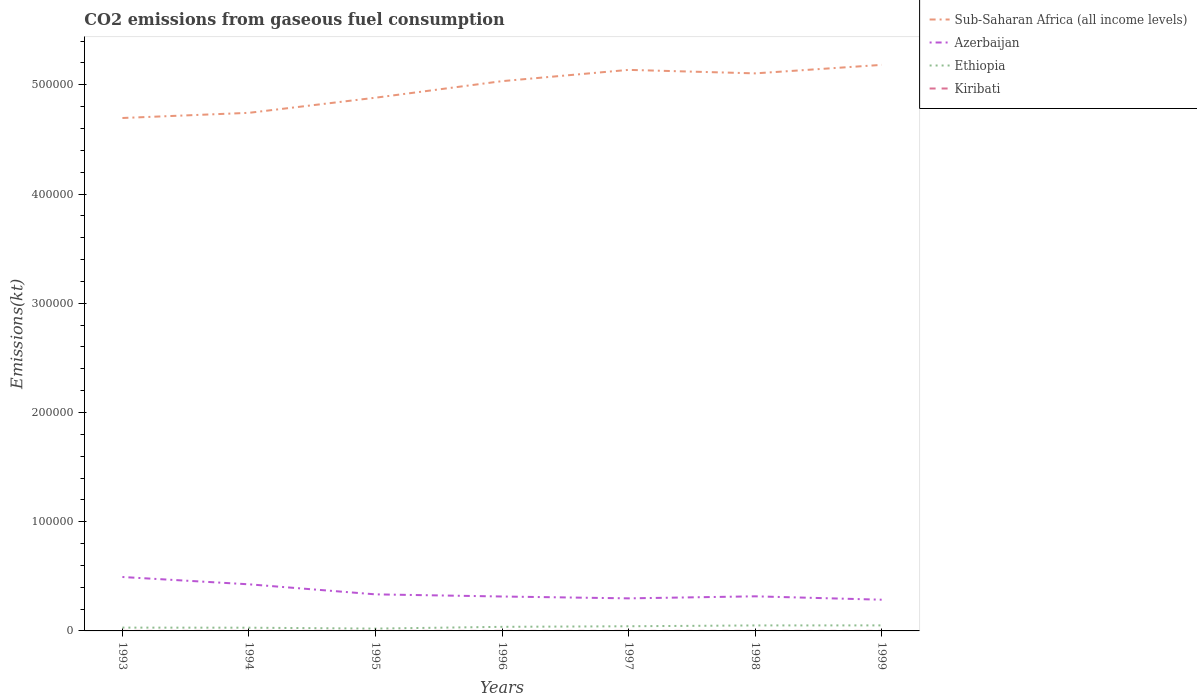How many different coloured lines are there?
Offer a very short reply. 4. Does the line corresponding to Ethiopia intersect with the line corresponding to Azerbaijan?
Provide a short and direct response. No. Across all years, what is the maximum amount of CO2 emitted in Azerbaijan?
Your response must be concise. 2.86e+04. What is the total amount of CO2 emitted in Sub-Saharan Africa (all income levels) in the graph?
Your answer should be very brief. 3200.52. What is the difference between the highest and the second highest amount of CO2 emitted in Azerbaijan?
Your answer should be very brief. 2.08e+04. What is the difference between the highest and the lowest amount of CO2 emitted in Ethiopia?
Ensure brevity in your answer.  3. How many lines are there?
Offer a terse response. 4. Are the values on the major ticks of Y-axis written in scientific E-notation?
Your response must be concise. No. Where does the legend appear in the graph?
Your answer should be very brief. Top right. What is the title of the graph?
Your response must be concise. CO2 emissions from gaseous fuel consumption. What is the label or title of the X-axis?
Provide a short and direct response. Years. What is the label or title of the Y-axis?
Offer a very short reply. Emissions(kt). What is the Emissions(kt) of Sub-Saharan Africa (all income levels) in 1993?
Provide a succinct answer. 4.70e+05. What is the Emissions(kt) in Azerbaijan in 1993?
Your answer should be compact. 4.94e+04. What is the Emissions(kt) in Ethiopia in 1993?
Offer a very short reply. 3028.94. What is the Emissions(kt) of Kiribati in 1993?
Make the answer very short. 22. What is the Emissions(kt) in Sub-Saharan Africa (all income levels) in 1994?
Ensure brevity in your answer.  4.74e+05. What is the Emissions(kt) in Azerbaijan in 1994?
Ensure brevity in your answer.  4.27e+04. What is the Emissions(kt) of Ethiopia in 1994?
Your answer should be very brief. 2948.27. What is the Emissions(kt) in Kiribati in 1994?
Provide a short and direct response. 22. What is the Emissions(kt) in Sub-Saharan Africa (all income levels) in 1995?
Make the answer very short. 4.88e+05. What is the Emissions(kt) in Azerbaijan in 1995?
Your answer should be compact. 3.35e+04. What is the Emissions(kt) in Ethiopia in 1995?
Your answer should be very brief. 2145.2. What is the Emissions(kt) of Kiribati in 1995?
Give a very brief answer. 22. What is the Emissions(kt) in Sub-Saharan Africa (all income levels) in 1996?
Provide a succinct answer. 5.03e+05. What is the Emissions(kt) in Azerbaijan in 1996?
Ensure brevity in your answer.  3.15e+04. What is the Emissions(kt) in Ethiopia in 1996?
Keep it short and to the point. 3744.01. What is the Emissions(kt) in Kiribati in 1996?
Provide a short and direct response. 36.67. What is the Emissions(kt) of Sub-Saharan Africa (all income levels) in 1997?
Ensure brevity in your answer.  5.14e+05. What is the Emissions(kt) in Azerbaijan in 1997?
Your response must be concise. 2.98e+04. What is the Emissions(kt) in Ethiopia in 1997?
Ensure brevity in your answer.  4272.06. What is the Emissions(kt) of Kiribati in 1997?
Your response must be concise. 29.34. What is the Emissions(kt) in Sub-Saharan Africa (all income levels) in 1998?
Your answer should be very brief. 5.10e+05. What is the Emissions(kt) of Azerbaijan in 1998?
Your answer should be very brief. 3.17e+04. What is the Emissions(kt) in Ethiopia in 1998?
Make the answer very short. 5023.79. What is the Emissions(kt) of Kiribati in 1998?
Your answer should be compact. 33. What is the Emissions(kt) of Sub-Saharan Africa (all income levels) in 1999?
Your response must be concise. 5.18e+05. What is the Emissions(kt) in Azerbaijan in 1999?
Keep it short and to the point. 2.86e+04. What is the Emissions(kt) of Ethiopia in 1999?
Provide a short and direct response. 5064.13. What is the Emissions(kt) of Kiribati in 1999?
Your answer should be compact. 29.34. Across all years, what is the maximum Emissions(kt) in Sub-Saharan Africa (all income levels)?
Offer a terse response. 5.18e+05. Across all years, what is the maximum Emissions(kt) in Azerbaijan?
Ensure brevity in your answer.  4.94e+04. Across all years, what is the maximum Emissions(kt) in Ethiopia?
Offer a very short reply. 5064.13. Across all years, what is the maximum Emissions(kt) in Kiribati?
Make the answer very short. 36.67. Across all years, what is the minimum Emissions(kt) in Sub-Saharan Africa (all income levels)?
Your answer should be compact. 4.70e+05. Across all years, what is the minimum Emissions(kt) of Azerbaijan?
Provide a short and direct response. 2.86e+04. Across all years, what is the minimum Emissions(kt) of Ethiopia?
Your answer should be very brief. 2145.2. Across all years, what is the minimum Emissions(kt) of Kiribati?
Offer a terse response. 22. What is the total Emissions(kt) in Sub-Saharan Africa (all income levels) in the graph?
Give a very brief answer. 3.48e+06. What is the total Emissions(kt) in Azerbaijan in the graph?
Give a very brief answer. 2.47e+05. What is the total Emissions(kt) in Ethiopia in the graph?
Make the answer very short. 2.62e+04. What is the total Emissions(kt) of Kiribati in the graph?
Provide a succinct answer. 194.35. What is the difference between the Emissions(kt) in Sub-Saharan Africa (all income levels) in 1993 and that in 1994?
Offer a terse response. -4729.34. What is the difference between the Emissions(kt) in Azerbaijan in 1993 and that in 1994?
Your response must be concise. 6692.27. What is the difference between the Emissions(kt) of Ethiopia in 1993 and that in 1994?
Your response must be concise. 80.67. What is the difference between the Emissions(kt) in Kiribati in 1993 and that in 1994?
Your answer should be compact. 0. What is the difference between the Emissions(kt) in Sub-Saharan Africa (all income levels) in 1993 and that in 1995?
Your response must be concise. -1.86e+04. What is the difference between the Emissions(kt) of Azerbaijan in 1993 and that in 1995?
Offer a terse response. 1.59e+04. What is the difference between the Emissions(kt) in Ethiopia in 1993 and that in 1995?
Provide a short and direct response. 883.75. What is the difference between the Emissions(kt) in Kiribati in 1993 and that in 1995?
Keep it short and to the point. 0. What is the difference between the Emissions(kt) in Sub-Saharan Africa (all income levels) in 1993 and that in 1996?
Offer a very short reply. -3.37e+04. What is the difference between the Emissions(kt) of Azerbaijan in 1993 and that in 1996?
Make the answer very short. 1.79e+04. What is the difference between the Emissions(kt) in Ethiopia in 1993 and that in 1996?
Your answer should be compact. -715.07. What is the difference between the Emissions(kt) of Kiribati in 1993 and that in 1996?
Your answer should be compact. -14.67. What is the difference between the Emissions(kt) in Sub-Saharan Africa (all income levels) in 1993 and that in 1997?
Provide a short and direct response. -4.41e+04. What is the difference between the Emissions(kt) in Azerbaijan in 1993 and that in 1997?
Provide a short and direct response. 1.96e+04. What is the difference between the Emissions(kt) of Ethiopia in 1993 and that in 1997?
Offer a terse response. -1243.11. What is the difference between the Emissions(kt) in Kiribati in 1993 and that in 1997?
Ensure brevity in your answer.  -7.33. What is the difference between the Emissions(kt) in Sub-Saharan Africa (all income levels) in 1993 and that in 1998?
Give a very brief answer. -4.09e+04. What is the difference between the Emissions(kt) in Azerbaijan in 1993 and that in 1998?
Make the answer very short. 1.77e+04. What is the difference between the Emissions(kt) of Ethiopia in 1993 and that in 1998?
Give a very brief answer. -1994.85. What is the difference between the Emissions(kt) in Kiribati in 1993 and that in 1998?
Offer a terse response. -11. What is the difference between the Emissions(kt) in Sub-Saharan Africa (all income levels) in 1993 and that in 1999?
Make the answer very short. -4.86e+04. What is the difference between the Emissions(kt) in Azerbaijan in 1993 and that in 1999?
Provide a short and direct response. 2.08e+04. What is the difference between the Emissions(kt) of Ethiopia in 1993 and that in 1999?
Your answer should be compact. -2035.18. What is the difference between the Emissions(kt) of Kiribati in 1993 and that in 1999?
Your answer should be compact. -7.33. What is the difference between the Emissions(kt) in Sub-Saharan Africa (all income levels) in 1994 and that in 1995?
Give a very brief answer. -1.39e+04. What is the difference between the Emissions(kt) in Azerbaijan in 1994 and that in 1995?
Provide a short and direct response. 9193.17. What is the difference between the Emissions(kt) in Ethiopia in 1994 and that in 1995?
Keep it short and to the point. 803.07. What is the difference between the Emissions(kt) of Kiribati in 1994 and that in 1995?
Ensure brevity in your answer.  0. What is the difference between the Emissions(kt) in Sub-Saharan Africa (all income levels) in 1994 and that in 1996?
Make the answer very short. -2.90e+04. What is the difference between the Emissions(kt) in Azerbaijan in 1994 and that in 1996?
Keep it short and to the point. 1.12e+04. What is the difference between the Emissions(kt) of Ethiopia in 1994 and that in 1996?
Offer a terse response. -795.74. What is the difference between the Emissions(kt) in Kiribati in 1994 and that in 1996?
Your response must be concise. -14.67. What is the difference between the Emissions(kt) in Sub-Saharan Africa (all income levels) in 1994 and that in 1997?
Provide a succinct answer. -3.93e+04. What is the difference between the Emissions(kt) of Azerbaijan in 1994 and that in 1997?
Your answer should be compact. 1.29e+04. What is the difference between the Emissions(kt) of Ethiopia in 1994 and that in 1997?
Offer a terse response. -1323.79. What is the difference between the Emissions(kt) of Kiribati in 1994 and that in 1997?
Offer a terse response. -7.33. What is the difference between the Emissions(kt) in Sub-Saharan Africa (all income levels) in 1994 and that in 1998?
Your response must be concise. -3.61e+04. What is the difference between the Emissions(kt) in Azerbaijan in 1994 and that in 1998?
Provide a short and direct response. 1.10e+04. What is the difference between the Emissions(kt) in Ethiopia in 1994 and that in 1998?
Give a very brief answer. -2075.52. What is the difference between the Emissions(kt) of Kiribati in 1994 and that in 1998?
Ensure brevity in your answer.  -11. What is the difference between the Emissions(kt) of Sub-Saharan Africa (all income levels) in 1994 and that in 1999?
Provide a short and direct response. -4.39e+04. What is the difference between the Emissions(kt) of Azerbaijan in 1994 and that in 1999?
Make the answer very short. 1.41e+04. What is the difference between the Emissions(kt) of Ethiopia in 1994 and that in 1999?
Provide a succinct answer. -2115.86. What is the difference between the Emissions(kt) of Kiribati in 1994 and that in 1999?
Your answer should be very brief. -7.33. What is the difference between the Emissions(kt) of Sub-Saharan Africa (all income levels) in 1995 and that in 1996?
Your answer should be very brief. -1.52e+04. What is the difference between the Emissions(kt) in Azerbaijan in 1995 and that in 1996?
Provide a succinct answer. 1969.18. What is the difference between the Emissions(kt) of Ethiopia in 1995 and that in 1996?
Your answer should be very brief. -1598.81. What is the difference between the Emissions(kt) of Kiribati in 1995 and that in 1996?
Make the answer very short. -14.67. What is the difference between the Emissions(kt) of Sub-Saharan Africa (all income levels) in 1995 and that in 1997?
Your answer should be compact. -2.55e+04. What is the difference between the Emissions(kt) of Azerbaijan in 1995 and that in 1997?
Keep it short and to the point. 3670.67. What is the difference between the Emissions(kt) in Ethiopia in 1995 and that in 1997?
Give a very brief answer. -2126.86. What is the difference between the Emissions(kt) of Kiribati in 1995 and that in 1997?
Provide a succinct answer. -7.33. What is the difference between the Emissions(kt) in Sub-Saharan Africa (all income levels) in 1995 and that in 1998?
Ensure brevity in your answer.  -2.23e+04. What is the difference between the Emissions(kt) in Azerbaijan in 1995 and that in 1998?
Your answer should be very brief. 1804.16. What is the difference between the Emissions(kt) of Ethiopia in 1995 and that in 1998?
Give a very brief answer. -2878.59. What is the difference between the Emissions(kt) of Kiribati in 1995 and that in 1998?
Make the answer very short. -11. What is the difference between the Emissions(kt) of Sub-Saharan Africa (all income levels) in 1995 and that in 1999?
Ensure brevity in your answer.  -3.01e+04. What is the difference between the Emissions(kt) of Azerbaijan in 1995 and that in 1999?
Your response must be concise. 4902.78. What is the difference between the Emissions(kt) of Ethiopia in 1995 and that in 1999?
Ensure brevity in your answer.  -2918.93. What is the difference between the Emissions(kt) of Kiribati in 1995 and that in 1999?
Ensure brevity in your answer.  -7.33. What is the difference between the Emissions(kt) in Sub-Saharan Africa (all income levels) in 1996 and that in 1997?
Keep it short and to the point. -1.03e+04. What is the difference between the Emissions(kt) in Azerbaijan in 1996 and that in 1997?
Your answer should be very brief. 1701.49. What is the difference between the Emissions(kt) in Ethiopia in 1996 and that in 1997?
Your answer should be very brief. -528.05. What is the difference between the Emissions(kt) in Kiribati in 1996 and that in 1997?
Your answer should be compact. 7.33. What is the difference between the Emissions(kt) in Sub-Saharan Africa (all income levels) in 1996 and that in 1998?
Offer a very short reply. -7122.09. What is the difference between the Emissions(kt) in Azerbaijan in 1996 and that in 1998?
Provide a short and direct response. -165.01. What is the difference between the Emissions(kt) of Ethiopia in 1996 and that in 1998?
Your answer should be compact. -1279.78. What is the difference between the Emissions(kt) of Kiribati in 1996 and that in 1998?
Your answer should be compact. 3.67. What is the difference between the Emissions(kt) of Sub-Saharan Africa (all income levels) in 1996 and that in 1999?
Make the answer very short. -1.49e+04. What is the difference between the Emissions(kt) in Azerbaijan in 1996 and that in 1999?
Provide a succinct answer. 2933.6. What is the difference between the Emissions(kt) of Ethiopia in 1996 and that in 1999?
Offer a very short reply. -1320.12. What is the difference between the Emissions(kt) in Kiribati in 1996 and that in 1999?
Give a very brief answer. 7.33. What is the difference between the Emissions(kt) in Sub-Saharan Africa (all income levels) in 1997 and that in 1998?
Your answer should be compact. 3200.52. What is the difference between the Emissions(kt) in Azerbaijan in 1997 and that in 1998?
Keep it short and to the point. -1866.5. What is the difference between the Emissions(kt) of Ethiopia in 1997 and that in 1998?
Make the answer very short. -751.74. What is the difference between the Emissions(kt) in Kiribati in 1997 and that in 1998?
Keep it short and to the point. -3.67. What is the difference between the Emissions(kt) in Sub-Saharan Africa (all income levels) in 1997 and that in 1999?
Ensure brevity in your answer.  -4576.38. What is the difference between the Emissions(kt) of Azerbaijan in 1997 and that in 1999?
Your answer should be very brief. 1232.11. What is the difference between the Emissions(kt) of Ethiopia in 1997 and that in 1999?
Keep it short and to the point. -792.07. What is the difference between the Emissions(kt) in Sub-Saharan Africa (all income levels) in 1998 and that in 1999?
Your answer should be compact. -7776.91. What is the difference between the Emissions(kt) in Azerbaijan in 1998 and that in 1999?
Provide a short and direct response. 3098.61. What is the difference between the Emissions(kt) in Ethiopia in 1998 and that in 1999?
Ensure brevity in your answer.  -40.34. What is the difference between the Emissions(kt) in Kiribati in 1998 and that in 1999?
Provide a short and direct response. 3.67. What is the difference between the Emissions(kt) in Sub-Saharan Africa (all income levels) in 1993 and the Emissions(kt) in Azerbaijan in 1994?
Your answer should be very brief. 4.27e+05. What is the difference between the Emissions(kt) in Sub-Saharan Africa (all income levels) in 1993 and the Emissions(kt) in Ethiopia in 1994?
Keep it short and to the point. 4.67e+05. What is the difference between the Emissions(kt) in Sub-Saharan Africa (all income levels) in 1993 and the Emissions(kt) in Kiribati in 1994?
Make the answer very short. 4.70e+05. What is the difference between the Emissions(kt) in Azerbaijan in 1993 and the Emissions(kt) in Ethiopia in 1994?
Ensure brevity in your answer.  4.64e+04. What is the difference between the Emissions(kt) in Azerbaijan in 1993 and the Emissions(kt) in Kiribati in 1994?
Provide a short and direct response. 4.93e+04. What is the difference between the Emissions(kt) in Ethiopia in 1993 and the Emissions(kt) in Kiribati in 1994?
Your response must be concise. 3006.94. What is the difference between the Emissions(kt) in Sub-Saharan Africa (all income levels) in 1993 and the Emissions(kt) in Azerbaijan in 1995?
Your answer should be very brief. 4.36e+05. What is the difference between the Emissions(kt) in Sub-Saharan Africa (all income levels) in 1993 and the Emissions(kt) in Ethiopia in 1995?
Your answer should be very brief. 4.67e+05. What is the difference between the Emissions(kt) in Sub-Saharan Africa (all income levels) in 1993 and the Emissions(kt) in Kiribati in 1995?
Your answer should be very brief. 4.70e+05. What is the difference between the Emissions(kt) of Azerbaijan in 1993 and the Emissions(kt) of Ethiopia in 1995?
Your answer should be very brief. 4.72e+04. What is the difference between the Emissions(kt) in Azerbaijan in 1993 and the Emissions(kt) in Kiribati in 1995?
Your response must be concise. 4.93e+04. What is the difference between the Emissions(kt) of Ethiopia in 1993 and the Emissions(kt) of Kiribati in 1995?
Make the answer very short. 3006.94. What is the difference between the Emissions(kt) in Sub-Saharan Africa (all income levels) in 1993 and the Emissions(kt) in Azerbaijan in 1996?
Provide a short and direct response. 4.38e+05. What is the difference between the Emissions(kt) in Sub-Saharan Africa (all income levels) in 1993 and the Emissions(kt) in Ethiopia in 1996?
Your response must be concise. 4.66e+05. What is the difference between the Emissions(kt) in Sub-Saharan Africa (all income levels) in 1993 and the Emissions(kt) in Kiribati in 1996?
Offer a very short reply. 4.70e+05. What is the difference between the Emissions(kt) in Azerbaijan in 1993 and the Emissions(kt) in Ethiopia in 1996?
Provide a succinct answer. 4.56e+04. What is the difference between the Emissions(kt) in Azerbaijan in 1993 and the Emissions(kt) in Kiribati in 1996?
Your answer should be compact. 4.93e+04. What is the difference between the Emissions(kt) in Ethiopia in 1993 and the Emissions(kt) in Kiribati in 1996?
Your answer should be compact. 2992.27. What is the difference between the Emissions(kt) of Sub-Saharan Africa (all income levels) in 1993 and the Emissions(kt) of Azerbaijan in 1997?
Ensure brevity in your answer.  4.40e+05. What is the difference between the Emissions(kt) of Sub-Saharan Africa (all income levels) in 1993 and the Emissions(kt) of Ethiopia in 1997?
Keep it short and to the point. 4.65e+05. What is the difference between the Emissions(kt) in Sub-Saharan Africa (all income levels) in 1993 and the Emissions(kt) in Kiribati in 1997?
Make the answer very short. 4.70e+05. What is the difference between the Emissions(kt) in Azerbaijan in 1993 and the Emissions(kt) in Ethiopia in 1997?
Make the answer very short. 4.51e+04. What is the difference between the Emissions(kt) of Azerbaijan in 1993 and the Emissions(kt) of Kiribati in 1997?
Your answer should be very brief. 4.93e+04. What is the difference between the Emissions(kt) of Ethiopia in 1993 and the Emissions(kt) of Kiribati in 1997?
Ensure brevity in your answer.  2999.61. What is the difference between the Emissions(kt) of Sub-Saharan Africa (all income levels) in 1993 and the Emissions(kt) of Azerbaijan in 1998?
Provide a short and direct response. 4.38e+05. What is the difference between the Emissions(kt) of Sub-Saharan Africa (all income levels) in 1993 and the Emissions(kt) of Ethiopia in 1998?
Give a very brief answer. 4.65e+05. What is the difference between the Emissions(kt) of Sub-Saharan Africa (all income levels) in 1993 and the Emissions(kt) of Kiribati in 1998?
Your response must be concise. 4.70e+05. What is the difference between the Emissions(kt) of Azerbaijan in 1993 and the Emissions(kt) of Ethiopia in 1998?
Offer a very short reply. 4.43e+04. What is the difference between the Emissions(kt) of Azerbaijan in 1993 and the Emissions(kt) of Kiribati in 1998?
Provide a succinct answer. 4.93e+04. What is the difference between the Emissions(kt) in Ethiopia in 1993 and the Emissions(kt) in Kiribati in 1998?
Provide a short and direct response. 2995.94. What is the difference between the Emissions(kt) in Sub-Saharan Africa (all income levels) in 1993 and the Emissions(kt) in Azerbaijan in 1999?
Keep it short and to the point. 4.41e+05. What is the difference between the Emissions(kt) of Sub-Saharan Africa (all income levels) in 1993 and the Emissions(kt) of Ethiopia in 1999?
Make the answer very short. 4.65e+05. What is the difference between the Emissions(kt) in Sub-Saharan Africa (all income levels) in 1993 and the Emissions(kt) in Kiribati in 1999?
Your answer should be compact. 4.70e+05. What is the difference between the Emissions(kt) of Azerbaijan in 1993 and the Emissions(kt) of Ethiopia in 1999?
Provide a succinct answer. 4.43e+04. What is the difference between the Emissions(kt) of Azerbaijan in 1993 and the Emissions(kt) of Kiribati in 1999?
Ensure brevity in your answer.  4.93e+04. What is the difference between the Emissions(kt) in Ethiopia in 1993 and the Emissions(kt) in Kiribati in 1999?
Offer a very short reply. 2999.61. What is the difference between the Emissions(kt) of Sub-Saharan Africa (all income levels) in 1994 and the Emissions(kt) of Azerbaijan in 1995?
Provide a succinct answer. 4.41e+05. What is the difference between the Emissions(kt) of Sub-Saharan Africa (all income levels) in 1994 and the Emissions(kt) of Ethiopia in 1995?
Provide a short and direct response. 4.72e+05. What is the difference between the Emissions(kt) in Sub-Saharan Africa (all income levels) in 1994 and the Emissions(kt) in Kiribati in 1995?
Keep it short and to the point. 4.74e+05. What is the difference between the Emissions(kt) in Azerbaijan in 1994 and the Emissions(kt) in Ethiopia in 1995?
Give a very brief answer. 4.05e+04. What is the difference between the Emissions(kt) in Azerbaijan in 1994 and the Emissions(kt) in Kiribati in 1995?
Offer a very short reply. 4.27e+04. What is the difference between the Emissions(kt) in Ethiopia in 1994 and the Emissions(kt) in Kiribati in 1995?
Provide a short and direct response. 2926.27. What is the difference between the Emissions(kt) of Sub-Saharan Africa (all income levels) in 1994 and the Emissions(kt) of Azerbaijan in 1996?
Your answer should be very brief. 4.43e+05. What is the difference between the Emissions(kt) in Sub-Saharan Africa (all income levels) in 1994 and the Emissions(kt) in Ethiopia in 1996?
Your response must be concise. 4.71e+05. What is the difference between the Emissions(kt) in Sub-Saharan Africa (all income levels) in 1994 and the Emissions(kt) in Kiribati in 1996?
Give a very brief answer. 4.74e+05. What is the difference between the Emissions(kt) of Azerbaijan in 1994 and the Emissions(kt) of Ethiopia in 1996?
Your answer should be compact. 3.89e+04. What is the difference between the Emissions(kt) of Azerbaijan in 1994 and the Emissions(kt) of Kiribati in 1996?
Your answer should be compact. 4.26e+04. What is the difference between the Emissions(kt) in Ethiopia in 1994 and the Emissions(kt) in Kiribati in 1996?
Offer a very short reply. 2911.6. What is the difference between the Emissions(kt) in Sub-Saharan Africa (all income levels) in 1994 and the Emissions(kt) in Azerbaijan in 1997?
Provide a succinct answer. 4.45e+05. What is the difference between the Emissions(kt) in Sub-Saharan Africa (all income levels) in 1994 and the Emissions(kt) in Ethiopia in 1997?
Your response must be concise. 4.70e+05. What is the difference between the Emissions(kt) of Sub-Saharan Africa (all income levels) in 1994 and the Emissions(kt) of Kiribati in 1997?
Your response must be concise. 4.74e+05. What is the difference between the Emissions(kt) in Azerbaijan in 1994 and the Emissions(kt) in Ethiopia in 1997?
Your response must be concise. 3.84e+04. What is the difference between the Emissions(kt) in Azerbaijan in 1994 and the Emissions(kt) in Kiribati in 1997?
Your answer should be compact. 4.26e+04. What is the difference between the Emissions(kt) of Ethiopia in 1994 and the Emissions(kt) of Kiribati in 1997?
Keep it short and to the point. 2918.93. What is the difference between the Emissions(kt) in Sub-Saharan Africa (all income levels) in 1994 and the Emissions(kt) in Azerbaijan in 1998?
Give a very brief answer. 4.43e+05. What is the difference between the Emissions(kt) in Sub-Saharan Africa (all income levels) in 1994 and the Emissions(kt) in Ethiopia in 1998?
Provide a succinct answer. 4.69e+05. What is the difference between the Emissions(kt) in Sub-Saharan Africa (all income levels) in 1994 and the Emissions(kt) in Kiribati in 1998?
Keep it short and to the point. 4.74e+05. What is the difference between the Emissions(kt) in Azerbaijan in 1994 and the Emissions(kt) in Ethiopia in 1998?
Offer a terse response. 3.76e+04. What is the difference between the Emissions(kt) in Azerbaijan in 1994 and the Emissions(kt) in Kiribati in 1998?
Give a very brief answer. 4.26e+04. What is the difference between the Emissions(kt) of Ethiopia in 1994 and the Emissions(kt) of Kiribati in 1998?
Keep it short and to the point. 2915.26. What is the difference between the Emissions(kt) in Sub-Saharan Africa (all income levels) in 1994 and the Emissions(kt) in Azerbaijan in 1999?
Provide a short and direct response. 4.46e+05. What is the difference between the Emissions(kt) in Sub-Saharan Africa (all income levels) in 1994 and the Emissions(kt) in Ethiopia in 1999?
Keep it short and to the point. 4.69e+05. What is the difference between the Emissions(kt) in Sub-Saharan Africa (all income levels) in 1994 and the Emissions(kt) in Kiribati in 1999?
Your response must be concise. 4.74e+05. What is the difference between the Emissions(kt) in Azerbaijan in 1994 and the Emissions(kt) in Ethiopia in 1999?
Offer a very short reply. 3.76e+04. What is the difference between the Emissions(kt) in Azerbaijan in 1994 and the Emissions(kt) in Kiribati in 1999?
Provide a short and direct response. 4.26e+04. What is the difference between the Emissions(kt) in Ethiopia in 1994 and the Emissions(kt) in Kiribati in 1999?
Your answer should be compact. 2918.93. What is the difference between the Emissions(kt) in Sub-Saharan Africa (all income levels) in 1995 and the Emissions(kt) in Azerbaijan in 1996?
Provide a short and direct response. 4.57e+05. What is the difference between the Emissions(kt) of Sub-Saharan Africa (all income levels) in 1995 and the Emissions(kt) of Ethiopia in 1996?
Provide a succinct answer. 4.84e+05. What is the difference between the Emissions(kt) of Sub-Saharan Africa (all income levels) in 1995 and the Emissions(kt) of Kiribati in 1996?
Make the answer very short. 4.88e+05. What is the difference between the Emissions(kt) of Azerbaijan in 1995 and the Emissions(kt) of Ethiopia in 1996?
Keep it short and to the point. 2.97e+04. What is the difference between the Emissions(kt) in Azerbaijan in 1995 and the Emissions(kt) in Kiribati in 1996?
Keep it short and to the point. 3.34e+04. What is the difference between the Emissions(kt) in Ethiopia in 1995 and the Emissions(kt) in Kiribati in 1996?
Provide a succinct answer. 2108.53. What is the difference between the Emissions(kt) of Sub-Saharan Africa (all income levels) in 1995 and the Emissions(kt) of Azerbaijan in 1997?
Give a very brief answer. 4.58e+05. What is the difference between the Emissions(kt) of Sub-Saharan Africa (all income levels) in 1995 and the Emissions(kt) of Ethiopia in 1997?
Your answer should be very brief. 4.84e+05. What is the difference between the Emissions(kt) of Sub-Saharan Africa (all income levels) in 1995 and the Emissions(kt) of Kiribati in 1997?
Your answer should be very brief. 4.88e+05. What is the difference between the Emissions(kt) in Azerbaijan in 1995 and the Emissions(kt) in Ethiopia in 1997?
Your response must be concise. 2.92e+04. What is the difference between the Emissions(kt) of Azerbaijan in 1995 and the Emissions(kt) of Kiribati in 1997?
Ensure brevity in your answer.  3.35e+04. What is the difference between the Emissions(kt) of Ethiopia in 1995 and the Emissions(kt) of Kiribati in 1997?
Your answer should be compact. 2115.86. What is the difference between the Emissions(kt) of Sub-Saharan Africa (all income levels) in 1995 and the Emissions(kt) of Azerbaijan in 1998?
Offer a terse response. 4.57e+05. What is the difference between the Emissions(kt) of Sub-Saharan Africa (all income levels) in 1995 and the Emissions(kt) of Ethiopia in 1998?
Provide a short and direct response. 4.83e+05. What is the difference between the Emissions(kt) in Sub-Saharan Africa (all income levels) in 1995 and the Emissions(kt) in Kiribati in 1998?
Offer a very short reply. 4.88e+05. What is the difference between the Emissions(kt) in Azerbaijan in 1995 and the Emissions(kt) in Ethiopia in 1998?
Your response must be concise. 2.85e+04. What is the difference between the Emissions(kt) in Azerbaijan in 1995 and the Emissions(kt) in Kiribati in 1998?
Give a very brief answer. 3.34e+04. What is the difference between the Emissions(kt) of Ethiopia in 1995 and the Emissions(kt) of Kiribati in 1998?
Provide a succinct answer. 2112.19. What is the difference between the Emissions(kt) of Sub-Saharan Africa (all income levels) in 1995 and the Emissions(kt) of Azerbaijan in 1999?
Give a very brief answer. 4.60e+05. What is the difference between the Emissions(kt) in Sub-Saharan Africa (all income levels) in 1995 and the Emissions(kt) in Ethiopia in 1999?
Your answer should be compact. 4.83e+05. What is the difference between the Emissions(kt) of Sub-Saharan Africa (all income levels) in 1995 and the Emissions(kt) of Kiribati in 1999?
Offer a terse response. 4.88e+05. What is the difference between the Emissions(kt) in Azerbaijan in 1995 and the Emissions(kt) in Ethiopia in 1999?
Your answer should be compact. 2.84e+04. What is the difference between the Emissions(kt) of Azerbaijan in 1995 and the Emissions(kt) of Kiribati in 1999?
Ensure brevity in your answer.  3.35e+04. What is the difference between the Emissions(kt) in Ethiopia in 1995 and the Emissions(kt) in Kiribati in 1999?
Provide a succinct answer. 2115.86. What is the difference between the Emissions(kt) of Sub-Saharan Africa (all income levels) in 1996 and the Emissions(kt) of Azerbaijan in 1997?
Give a very brief answer. 4.74e+05. What is the difference between the Emissions(kt) of Sub-Saharan Africa (all income levels) in 1996 and the Emissions(kt) of Ethiopia in 1997?
Your response must be concise. 4.99e+05. What is the difference between the Emissions(kt) of Sub-Saharan Africa (all income levels) in 1996 and the Emissions(kt) of Kiribati in 1997?
Give a very brief answer. 5.03e+05. What is the difference between the Emissions(kt) of Azerbaijan in 1996 and the Emissions(kt) of Ethiopia in 1997?
Your answer should be very brief. 2.72e+04. What is the difference between the Emissions(kt) in Azerbaijan in 1996 and the Emissions(kt) in Kiribati in 1997?
Ensure brevity in your answer.  3.15e+04. What is the difference between the Emissions(kt) of Ethiopia in 1996 and the Emissions(kt) of Kiribati in 1997?
Offer a terse response. 3714.67. What is the difference between the Emissions(kt) in Sub-Saharan Africa (all income levels) in 1996 and the Emissions(kt) in Azerbaijan in 1998?
Ensure brevity in your answer.  4.72e+05. What is the difference between the Emissions(kt) of Sub-Saharan Africa (all income levels) in 1996 and the Emissions(kt) of Ethiopia in 1998?
Provide a succinct answer. 4.98e+05. What is the difference between the Emissions(kt) in Sub-Saharan Africa (all income levels) in 1996 and the Emissions(kt) in Kiribati in 1998?
Give a very brief answer. 5.03e+05. What is the difference between the Emissions(kt) in Azerbaijan in 1996 and the Emissions(kt) in Ethiopia in 1998?
Offer a terse response. 2.65e+04. What is the difference between the Emissions(kt) of Azerbaijan in 1996 and the Emissions(kt) of Kiribati in 1998?
Offer a terse response. 3.15e+04. What is the difference between the Emissions(kt) in Ethiopia in 1996 and the Emissions(kt) in Kiribati in 1998?
Give a very brief answer. 3711. What is the difference between the Emissions(kt) in Sub-Saharan Africa (all income levels) in 1996 and the Emissions(kt) in Azerbaijan in 1999?
Your answer should be very brief. 4.75e+05. What is the difference between the Emissions(kt) of Sub-Saharan Africa (all income levels) in 1996 and the Emissions(kt) of Ethiopia in 1999?
Give a very brief answer. 4.98e+05. What is the difference between the Emissions(kt) of Sub-Saharan Africa (all income levels) in 1996 and the Emissions(kt) of Kiribati in 1999?
Offer a very short reply. 5.03e+05. What is the difference between the Emissions(kt) in Azerbaijan in 1996 and the Emissions(kt) in Ethiopia in 1999?
Your response must be concise. 2.64e+04. What is the difference between the Emissions(kt) in Azerbaijan in 1996 and the Emissions(kt) in Kiribati in 1999?
Ensure brevity in your answer.  3.15e+04. What is the difference between the Emissions(kt) of Ethiopia in 1996 and the Emissions(kt) of Kiribati in 1999?
Give a very brief answer. 3714.67. What is the difference between the Emissions(kt) in Sub-Saharan Africa (all income levels) in 1997 and the Emissions(kt) in Azerbaijan in 1998?
Keep it short and to the point. 4.82e+05. What is the difference between the Emissions(kt) in Sub-Saharan Africa (all income levels) in 1997 and the Emissions(kt) in Ethiopia in 1998?
Offer a very short reply. 5.09e+05. What is the difference between the Emissions(kt) of Sub-Saharan Africa (all income levels) in 1997 and the Emissions(kt) of Kiribati in 1998?
Provide a short and direct response. 5.14e+05. What is the difference between the Emissions(kt) in Azerbaijan in 1997 and the Emissions(kt) in Ethiopia in 1998?
Make the answer very short. 2.48e+04. What is the difference between the Emissions(kt) in Azerbaijan in 1997 and the Emissions(kt) in Kiribati in 1998?
Keep it short and to the point. 2.98e+04. What is the difference between the Emissions(kt) in Ethiopia in 1997 and the Emissions(kt) in Kiribati in 1998?
Offer a terse response. 4239.05. What is the difference between the Emissions(kt) in Sub-Saharan Africa (all income levels) in 1997 and the Emissions(kt) in Azerbaijan in 1999?
Your answer should be very brief. 4.85e+05. What is the difference between the Emissions(kt) in Sub-Saharan Africa (all income levels) in 1997 and the Emissions(kt) in Ethiopia in 1999?
Give a very brief answer. 5.09e+05. What is the difference between the Emissions(kt) in Sub-Saharan Africa (all income levels) in 1997 and the Emissions(kt) in Kiribati in 1999?
Ensure brevity in your answer.  5.14e+05. What is the difference between the Emissions(kt) in Azerbaijan in 1997 and the Emissions(kt) in Ethiopia in 1999?
Give a very brief answer. 2.47e+04. What is the difference between the Emissions(kt) of Azerbaijan in 1997 and the Emissions(kt) of Kiribati in 1999?
Offer a very short reply. 2.98e+04. What is the difference between the Emissions(kt) in Ethiopia in 1997 and the Emissions(kt) in Kiribati in 1999?
Give a very brief answer. 4242.72. What is the difference between the Emissions(kt) of Sub-Saharan Africa (all income levels) in 1998 and the Emissions(kt) of Azerbaijan in 1999?
Your response must be concise. 4.82e+05. What is the difference between the Emissions(kt) of Sub-Saharan Africa (all income levels) in 1998 and the Emissions(kt) of Ethiopia in 1999?
Your response must be concise. 5.05e+05. What is the difference between the Emissions(kt) of Sub-Saharan Africa (all income levels) in 1998 and the Emissions(kt) of Kiribati in 1999?
Your answer should be very brief. 5.10e+05. What is the difference between the Emissions(kt) in Azerbaijan in 1998 and the Emissions(kt) in Ethiopia in 1999?
Provide a succinct answer. 2.66e+04. What is the difference between the Emissions(kt) of Azerbaijan in 1998 and the Emissions(kt) of Kiribati in 1999?
Provide a short and direct response. 3.16e+04. What is the difference between the Emissions(kt) in Ethiopia in 1998 and the Emissions(kt) in Kiribati in 1999?
Give a very brief answer. 4994.45. What is the average Emissions(kt) in Sub-Saharan Africa (all income levels) per year?
Give a very brief answer. 4.97e+05. What is the average Emissions(kt) of Azerbaijan per year?
Provide a short and direct response. 3.53e+04. What is the average Emissions(kt) of Ethiopia per year?
Provide a succinct answer. 3746.63. What is the average Emissions(kt) of Kiribati per year?
Your response must be concise. 27.76. In the year 1993, what is the difference between the Emissions(kt) of Sub-Saharan Africa (all income levels) and Emissions(kt) of Azerbaijan?
Provide a succinct answer. 4.20e+05. In the year 1993, what is the difference between the Emissions(kt) in Sub-Saharan Africa (all income levels) and Emissions(kt) in Ethiopia?
Give a very brief answer. 4.67e+05. In the year 1993, what is the difference between the Emissions(kt) in Sub-Saharan Africa (all income levels) and Emissions(kt) in Kiribati?
Keep it short and to the point. 4.70e+05. In the year 1993, what is the difference between the Emissions(kt) in Azerbaijan and Emissions(kt) in Ethiopia?
Keep it short and to the point. 4.63e+04. In the year 1993, what is the difference between the Emissions(kt) in Azerbaijan and Emissions(kt) in Kiribati?
Your answer should be compact. 4.93e+04. In the year 1993, what is the difference between the Emissions(kt) in Ethiopia and Emissions(kt) in Kiribati?
Make the answer very short. 3006.94. In the year 1994, what is the difference between the Emissions(kt) in Sub-Saharan Africa (all income levels) and Emissions(kt) in Azerbaijan?
Offer a terse response. 4.32e+05. In the year 1994, what is the difference between the Emissions(kt) of Sub-Saharan Africa (all income levels) and Emissions(kt) of Ethiopia?
Provide a succinct answer. 4.71e+05. In the year 1994, what is the difference between the Emissions(kt) of Sub-Saharan Africa (all income levels) and Emissions(kt) of Kiribati?
Ensure brevity in your answer.  4.74e+05. In the year 1994, what is the difference between the Emissions(kt) of Azerbaijan and Emissions(kt) of Ethiopia?
Provide a short and direct response. 3.97e+04. In the year 1994, what is the difference between the Emissions(kt) in Azerbaijan and Emissions(kt) in Kiribati?
Give a very brief answer. 4.27e+04. In the year 1994, what is the difference between the Emissions(kt) in Ethiopia and Emissions(kt) in Kiribati?
Make the answer very short. 2926.27. In the year 1995, what is the difference between the Emissions(kt) in Sub-Saharan Africa (all income levels) and Emissions(kt) in Azerbaijan?
Offer a very short reply. 4.55e+05. In the year 1995, what is the difference between the Emissions(kt) in Sub-Saharan Africa (all income levels) and Emissions(kt) in Ethiopia?
Your response must be concise. 4.86e+05. In the year 1995, what is the difference between the Emissions(kt) of Sub-Saharan Africa (all income levels) and Emissions(kt) of Kiribati?
Your response must be concise. 4.88e+05. In the year 1995, what is the difference between the Emissions(kt) in Azerbaijan and Emissions(kt) in Ethiopia?
Ensure brevity in your answer.  3.13e+04. In the year 1995, what is the difference between the Emissions(kt) in Azerbaijan and Emissions(kt) in Kiribati?
Your response must be concise. 3.35e+04. In the year 1995, what is the difference between the Emissions(kt) in Ethiopia and Emissions(kt) in Kiribati?
Provide a succinct answer. 2123.19. In the year 1996, what is the difference between the Emissions(kt) of Sub-Saharan Africa (all income levels) and Emissions(kt) of Azerbaijan?
Ensure brevity in your answer.  4.72e+05. In the year 1996, what is the difference between the Emissions(kt) of Sub-Saharan Africa (all income levels) and Emissions(kt) of Ethiopia?
Ensure brevity in your answer.  5.00e+05. In the year 1996, what is the difference between the Emissions(kt) of Sub-Saharan Africa (all income levels) and Emissions(kt) of Kiribati?
Offer a very short reply. 5.03e+05. In the year 1996, what is the difference between the Emissions(kt) of Azerbaijan and Emissions(kt) of Ethiopia?
Keep it short and to the point. 2.78e+04. In the year 1996, what is the difference between the Emissions(kt) in Azerbaijan and Emissions(kt) in Kiribati?
Ensure brevity in your answer.  3.15e+04. In the year 1996, what is the difference between the Emissions(kt) of Ethiopia and Emissions(kt) of Kiribati?
Your answer should be compact. 3707.34. In the year 1997, what is the difference between the Emissions(kt) of Sub-Saharan Africa (all income levels) and Emissions(kt) of Azerbaijan?
Keep it short and to the point. 4.84e+05. In the year 1997, what is the difference between the Emissions(kt) in Sub-Saharan Africa (all income levels) and Emissions(kt) in Ethiopia?
Ensure brevity in your answer.  5.09e+05. In the year 1997, what is the difference between the Emissions(kt) of Sub-Saharan Africa (all income levels) and Emissions(kt) of Kiribati?
Offer a terse response. 5.14e+05. In the year 1997, what is the difference between the Emissions(kt) of Azerbaijan and Emissions(kt) of Ethiopia?
Offer a terse response. 2.55e+04. In the year 1997, what is the difference between the Emissions(kt) of Azerbaijan and Emissions(kt) of Kiribati?
Offer a very short reply. 2.98e+04. In the year 1997, what is the difference between the Emissions(kt) of Ethiopia and Emissions(kt) of Kiribati?
Keep it short and to the point. 4242.72. In the year 1998, what is the difference between the Emissions(kt) in Sub-Saharan Africa (all income levels) and Emissions(kt) in Azerbaijan?
Keep it short and to the point. 4.79e+05. In the year 1998, what is the difference between the Emissions(kt) in Sub-Saharan Africa (all income levels) and Emissions(kt) in Ethiopia?
Make the answer very short. 5.05e+05. In the year 1998, what is the difference between the Emissions(kt) of Sub-Saharan Africa (all income levels) and Emissions(kt) of Kiribati?
Your response must be concise. 5.10e+05. In the year 1998, what is the difference between the Emissions(kt) in Azerbaijan and Emissions(kt) in Ethiopia?
Give a very brief answer. 2.67e+04. In the year 1998, what is the difference between the Emissions(kt) in Azerbaijan and Emissions(kt) in Kiribati?
Your response must be concise. 3.16e+04. In the year 1998, what is the difference between the Emissions(kt) of Ethiopia and Emissions(kt) of Kiribati?
Provide a short and direct response. 4990.79. In the year 1999, what is the difference between the Emissions(kt) in Sub-Saharan Africa (all income levels) and Emissions(kt) in Azerbaijan?
Offer a very short reply. 4.90e+05. In the year 1999, what is the difference between the Emissions(kt) of Sub-Saharan Africa (all income levels) and Emissions(kt) of Ethiopia?
Your response must be concise. 5.13e+05. In the year 1999, what is the difference between the Emissions(kt) of Sub-Saharan Africa (all income levels) and Emissions(kt) of Kiribati?
Provide a succinct answer. 5.18e+05. In the year 1999, what is the difference between the Emissions(kt) in Azerbaijan and Emissions(kt) in Ethiopia?
Make the answer very short. 2.35e+04. In the year 1999, what is the difference between the Emissions(kt) of Azerbaijan and Emissions(kt) of Kiribati?
Offer a terse response. 2.85e+04. In the year 1999, what is the difference between the Emissions(kt) in Ethiopia and Emissions(kt) in Kiribati?
Make the answer very short. 5034.79. What is the ratio of the Emissions(kt) of Sub-Saharan Africa (all income levels) in 1993 to that in 1994?
Your answer should be compact. 0.99. What is the ratio of the Emissions(kt) in Azerbaijan in 1993 to that in 1994?
Provide a short and direct response. 1.16. What is the ratio of the Emissions(kt) in Ethiopia in 1993 to that in 1994?
Offer a very short reply. 1.03. What is the ratio of the Emissions(kt) of Kiribati in 1993 to that in 1994?
Provide a succinct answer. 1. What is the ratio of the Emissions(kt) of Sub-Saharan Africa (all income levels) in 1993 to that in 1995?
Keep it short and to the point. 0.96. What is the ratio of the Emissions(kt) in Azerbaijan in 1993 to that in 1995?
Your response must be concise. 1.47. What is the ratio of the Emissions(kt) of Ethiopia in 1993 to that in 1995?
Provide a succinct answer. 1.41. What is the ratio of the Emissions(kt) in Kiribati in 1993 to that in 1995?
Keep it short and to the point. 1. What is the ratio of the Emissions(kt) of Sub-Saharan Africa (all income levels) in 1993 to that in 1996?
Provide a succinct answer. 0.93. What is the ratio of the Emissions(kt) of Azerbaijan in 1993 to that in 1996?
Give a very brief answer. 1.57. What is the ratio of the Emissions(kt) in Ethiopia in 1993 to that in 1996?
Your answer should be very brief. 0.81. What is the ratio of the Emissions(kt) in Kiribati in 1993 to that in 1996?
Offer a very short reply. 0.6. What is the ratio of the Emissions(kt) of Sub-Saharan Africa (all income levels) in 1993 to that in 1997?
Ensure brevity in your answer.  0.91. What is the ratio of the Emissions(kt) in Azerbaijan in 1993 to that in 1997?
Ensure brevity in your answer.  1.66. What is the ratio of the Emissions(kt) of Ethiopia in 1993 to that in 1997?
Your response must be concise. 0.71. What is the ratio of the Emissions(kt) of Kiribati in 1993 to that in 1997?
Offer a very short reply. 0.75. What is the ratio of the Emissions(kt) of Azerbaijan in 1993 to that in 1998?
Give a very brief answer. 1.56. What is the ratio of the Emissions(kt) in Ethiopia in 1993 to that in 1998?
Keep it short and to the point. 0.6. What is the ratio of the Emissions(kt) of Sub-Saharan Africa (all income levels) in 1993 to that in 1999?
Make the answer very short. 0.91. What is the ratio of the Emissions(kt) of Azerbaijan in 1993 to that in 1999?
Offer a very short reply. 1.73. What is the ratio of the Emissions(kt) of Ethiopia in 1993 to that in 1999?
Give a very brief answer. 0.6. What is the ratio of the Emissions(kt) of Kiribati in 1993 to that in 1999?
Offer a very short reply. 0.75. What is the ratio of the Emissions(kt) in Sub-Saharan Africa (all income levels) in 1994 to that in 1995?
Your answer should be very brief. 0.97. What is the ratio of the Emissions(kt) in Azerbaijan in 1994 to that in 1995?
Offer a very short reply. 1.27. What is the ratio of the Emissions(kt) in Ethiopia in 1994 to that in 1995?
Keep it short and to the point. 1.37. What is the ratio of the Emissions(kt) in Kiribati in 1994 to that in 1995?
Make the answer very short. 1. What is the ratio of the Emissions(kt) in Sub-Saharan Africa (all income levels) in 1994 to that in 1996?
Your answer should be very brief. 0.94. What is the ratio of the Emissions(kt) in Azerbaijan in 1994 to that in 1996?
Provide a short and direct response. 1.35. What is the ratio of the Emissions(kt) of Ethiopia in 1994 to that in 1996?
Provide a short and direct response. 0.79. What is the ratio of the Emissions(kt) in Sub-Saharan Africa (all income levels) in 1994 to that in 1997?
Give a very brief answer. 0.92. What is the ratio of the Emissions(kt) of Azerbaijan in 1994 to that in 1997?
Your response must be concise. 1.43. What is the ratio of the Emissions(kt) of Ethiopia in 1994 to that in 1997?
Offer a very short reply. 0.69. What is the ratio of the Emissions(kt) of Sub-Saharan Africa (all income levels) in 1994 to that in 1998?
Your answer should be very brief. 0.93. What is the ratio of the Emissions(kt) in Azerbaijan in 1994 to that in 1998?
Provide a short and direct response. 1.35. What is the ratio of the Emissions(kt) in Ethiopia in 1994 to that in 1998?
Keep it short and to the point. 0.59. What is the ratio of the Emissions(kt) of Sub-Saharan Africa (all income levels) in 1994 to that in 1999?
Offer a very short reply. 0.92. What is the ratio of the Emissions(kt) of Azerbaijan in 1994 to that in 1999?
Your answer should be very brief. 1.49. What is the ratio of the Emissions(kt) in Ethiopia in 1994 to that in 1999?
Offer a very short reply. 0.58. What is the ratio of the Emissions(kt) of Sub-Saharan Africa (all income levels) in 1995 to that in 1996?
Your response must be concise. 0.97. What is the ratio of the Emissions(kt) of Azerbaijan in 1995 to that in 1996?
Ensure brevity in your answer.  1.06. What is the ratio of the Emissions(kt) in Ethiopia in 1995 to that in 1996?
Your answer should be compact. 0.57. What is the ratio of the Emissions(kt) in Sub-Saharan Africa (all income levels) in 1995 to that in 1997?
Keep it short and to the point. 0.95. What is the ratio of the Emissions(kt) of Azerbaijan in 1995 to that in 1997?
Offer a terse response. 1.12. What is the ratio of the Emissions(kt) of Ethiopia in 1995 to that in 1997?
Your answer should be very brief. 0.5. What is the ratio of the Emissions(kt) of Kiribati in 1995 to that in 1997?
Provide a short and direct response. 0.75. What is the ratio of the Emissions(kt) in Sub-Saharan Africa (all income levels) in 1995 to that in 1998?
Provide a succinct answer. 0.96. What is the ratio of the Emissions(kt) of Azerbaijan in 1995 to that in 1998?
Offer a terse response. 1.06. What is the ratio of the Emissions(kt) of Ethiopia in 1995 to that in 1998?
Give a very brief answer. 0.43. What is the ratio of the Emissions(kt) in Sub-Saharan Africa (all income levels) in 1995 to that in 1999?
Keep it short and to the point. 0.94. What is the ratio of the Emissions(kt) in Azerbaijan in 1995 to that in 1999?
Provide a succinct answer. 1.17. What is the ratio of the Emissions(kt) of Ethiopia in 1995 to that in 1999?
Make the answer very short. 0.42. What is the ratio of the Emissions(kt) in Sub-Saharan Africa (all income levels) in 1996 to that in 1997?
Ensure brevity in your answer.  0.98. What is the ratio of the Emissions(kt) in Azerbaijan in 1996 to that in 1997?
Offer a very short reply. 1.06. What is the ratio of the Emissions(kt) in Ethiopia in 1996 to that in 1997?
Offer a very short reply. 0.88. What is the ratio of the Emissions(kt) in Sub-Saharan Africa (all income levels) in 1996 to that in 1998?
Offer a very short reply. 0.99. What is the ratio of the Emissions(kt) in Ethiopia in 1996 to that in 1998?
Your response must be concise. 0.75. What is the ratio of the Emissions(kt) in Kiribati in 1996 to that in 1998?
Give a very brief answer. 1.11. What is the ratio of the Emissions(kt) of Sub-Saharan Africa (all income levels) in 1996 to that in 1999?
Make the answer very short. 0.97. What is the ratio of the Emissions(kt) of Azerbaijan in 1996 to that in 1999?
Keep it short and to the point. 1.1. What is the ratio of the Emissions(kt) in Ethiopia in 1996 to that in 1999?
Your answer should be very brief. 0.74. What is the ratio of the Emissions(kt) of Kiribati in 1996 to that in 1999?
Make the answer very short. 1.25. What is the ratio of the Emissions(kt) in Sub-Saharan Africa (all income levels) in 1997 to that in 1998?
Your answer should be compact. 1.01. What is the ratio of the Emissions(kt) of Azerbaijan in 1997 to that in 1998?
Give a very brief answer. 0.94. What is the ratio of the Emissions(kt) in Ethiopia in 1997 to that in 1998?
Your answer should be compact. 0.85. What is the ratio of the Emissions(kt) in Sub-Saharan Africa (all income levels) in 1997 to that in 1999?
Your answer should be compact. 0.99. What is the ratio of the Emissions(kt) of Azerbaijan in 1997 to that in 1999?
Offer a very short reply. 1.04. What is the ratio of the Emissions(kt) of Ethiopia in 1997 to that in 1999?
Provide a succinct answer. 0.84. What is the ratio of the Emissions(kt) of Azerbaijan in 1998 to that in 1999?
Make the answer very short. 1.11. What is the ratio of the Emissions(kt) in Ethiopia in 1998 to that in 1999?
Offer a terse response. 0.99. What is the ratio of the Emissions(kt) of Kiribati in 1998 to that in 1999?
Provide a succinct answer. 1.12. What is the difference between the highest and the second highest Emissions(kt) in Sub-Saharan Africa (all income levels)?
Ensure brevity in your answer.  4576.38. What is the difference between the highest and the second highest Emissions(kt) of Azerbaijan?
Give a very brief answer. 6692.27. What is the difference between the highest and the second highest Emissions(kt) of Ethiopia?
Give a very brief answer. 40.34. What is the difference between the highest and the second highest Emissions(kt) of Kiribati?
Provide a succinct answer. 3.67. What is the difference between the highest and the lowest Emissions(kt) in Sub-Saharan Africa (all income levels)?
Provide a succinct answer. 4.86e+04. What is the difference between the highest and the lowest Emissions(kt) of Azerbaijan?
Offer a very short reply. 2.08e+04. What is the difference between the highest and the lowest Emissions(kt) in Ethiopia?
Your answer should be very brief. 2918.93. What is the difference between the highest and the lowest Emissions(kt) of Kiribati?
Offer a terse response. 14.67. 